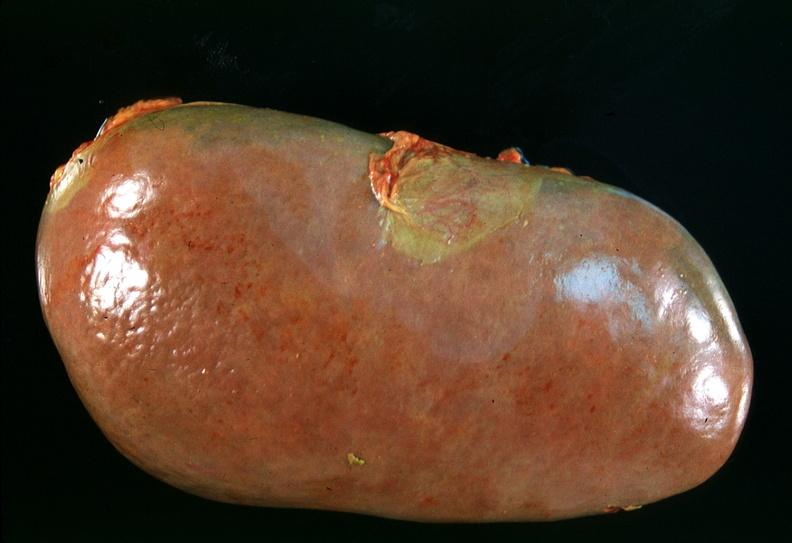what does this image show?
Answer the question using a single word or phrase. Spleen 